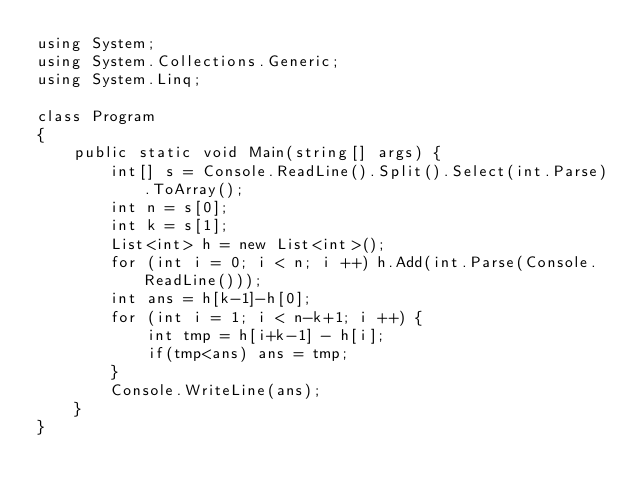Convert code to text. <code><loc_0><loc_0><loc_500><loc_500><_C#_>using System;
using System.Collections.Generic;
using System.Linq;

class Program
{
    public static void Main(string[] args) {
        int[] s = Console.ReadLine().Split().Select(int.Parse).ToArray();
        int n = s[0];
        int k = s[1];
        List<int> h = new List<int>();
        for (int i = 0; i < n; i ++) h.Add(int.Parse(Console.ReadLine()));
        int ans = h[k-1]-h[0];
        for (int i = 1; i < n-k+1; i ++) {
            int tmp = h[i+k-1] - h[i];
            if(tmp<ans) ans = tmp;
        }
        Console.WriteLine(ans);
    }
}</code> 